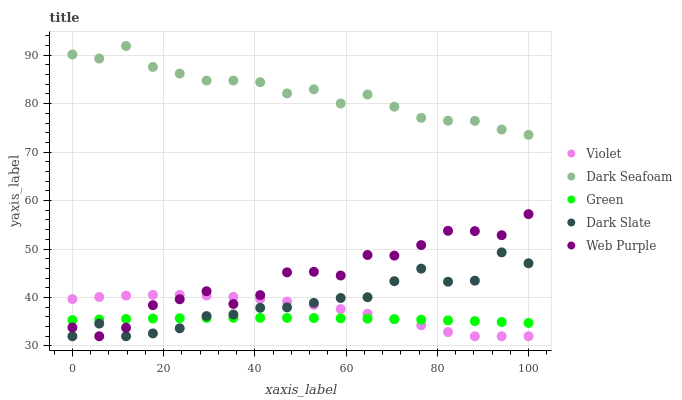Does Green have the minimum area under the curve?
Answer yes or no. Yes. Does Dark Seafoam have the maximum area under the curve?
Answer yes or no. Yes. Does Dark Seafoam have the minimum area under the curve?
Answer yes or no. No. Does Green have the maximum area under the curve?
Answer yes or no. No. Is Green the smoothest?
Answer yes or no. Yes. Is Web Purple the roughest?
Answer yes or no. Yes. Is Dark Seafoam the smoothest?
Answer yes or no. No. Is Dark Seafoam the roughest?
Answer yes or no. No. Does Dark Slate have the lowest value?
Answer yes or no. Yes. Does Green have the lowest value?
Answer yes or no. No. Does Dark Seafoam have the highest value?
Answer yes or no. Yes. Does Green have the highest value?
Answer yes or no. No. Is Web Purple less than Dark Seafoam?
Answer yes or no. Yes. Is Dark Seafoam greater than Web Purple?
Answer yes or no. Yes. Does Violet intersect Dark Slate?
Answer yes or no. Yes. Is Violet less than Dark Slate?
Answer yes or no. No. Is Violet greater than Dark Slate?
Answer yes or no. No. Does Web Purple intersect Dark Seafoam?
Answer yes or no. No. 